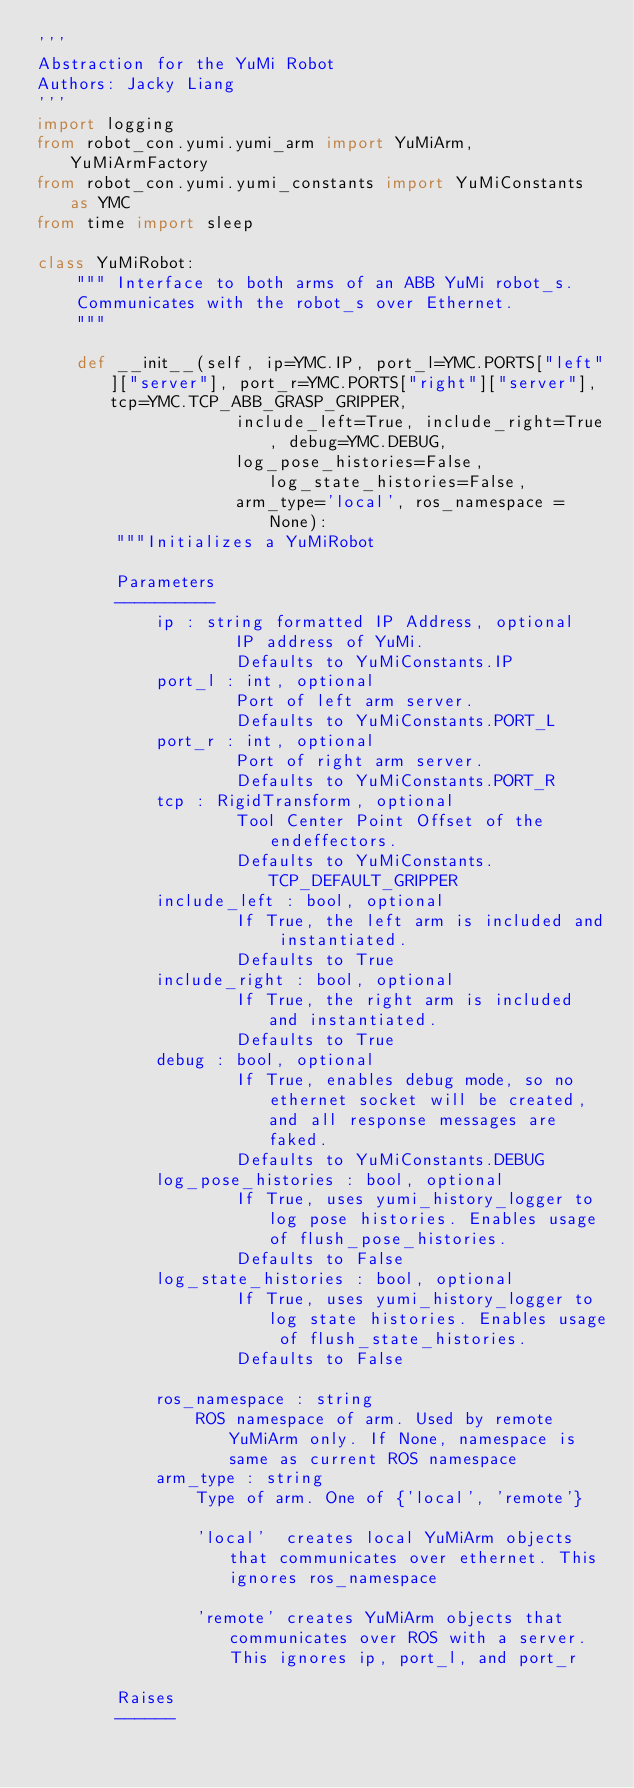Convert code to text. <code><loc_0><loc_0><loc_500><loc_500><_Python_>'''
Abstraction for the YuMi Robot
Authors: Jacky Liang
'''
import logging
from robot_con.yumi.yumi_arm import YuMiArm, YuMiArmFactory
from robot_con.yumi.yumi_constants import YuMiConstants as YMC
from time import sleep

class YuMiRobot:
    """ Interface to both arms of an ABB YuMi robot_s.
    Communicates with the robot_s over Ethernet.
    """

    def __init__(self, ip=YMC.IP, port_l=YMC.PORTS["left"]["server"], port_r=YMC.PORTS["right"]["server"], tcp=YMC.TCP_ABB_GRASP_GRIPPER,
                    include_left=True, include_right=True, debug=YMC.DEBUG,
                    log_pose_histories=False, log_state_histories=False,
                    arm_type='local', ros_namespace = None):
        """Initializes a YuMiRobot

        Parameters
        ----------
            ip : string formatted IP Address, optional
                    IP address of YuMi.
                    Defaults to YuMiConstants.IP
            port_l : int, optional
                    Port of left arm server.
                    Defaults to YuMiConstants.PORT_L
            port_r : int, optional
                    Port of right arm server.
                    Defaults to YuMiConstants.PORT_R
            tcp : RigidTransform, optional
                    Tool Center Point Offset of the endeffectors.
                    Defaults to YuMiConstants.TCP_DEFAULT_GRIPPER
            include_left : bool, optional
                    If True, the left arm is included and instantiated.
                    Defaults to True
            include_right : bool, optional
                    If True, the right arm is included and instantiated.
                    Defaults to True
            debug : bool, optional
                    If True, enables debug mode, so no ethernet socket will be created, and all response messages are faked.
                    Defaults to YuMiConstants.DEBUG
            log_pose_histories : bool, optional
                    If True, uses yumi_history_logger to log pose histories. Enables usage of flush_pose_histories.
                    Defaults to False
            log_state_histories : bool, optional
                    If True, uses yumi_history_logger to log state histories. Enables usage of flush_state_histories.
                    Defaults to False
                    
            ros_namespace : string
                ROS namespace of arm. Used by remote YuMiArm only. If None, namespace is same as current ROS namespace
            arm_type : string
                Type of arm. One of {'local', 'remote'}
            
                'local'  creates local YuMiArm objects that communicates over ethernet. This ignores ros_namespace
            
                'remote' creates YuMiArm objects that communicates over ROS with a server. This ignores ip, port_l, and port_r

        Raises
        ------</code> 